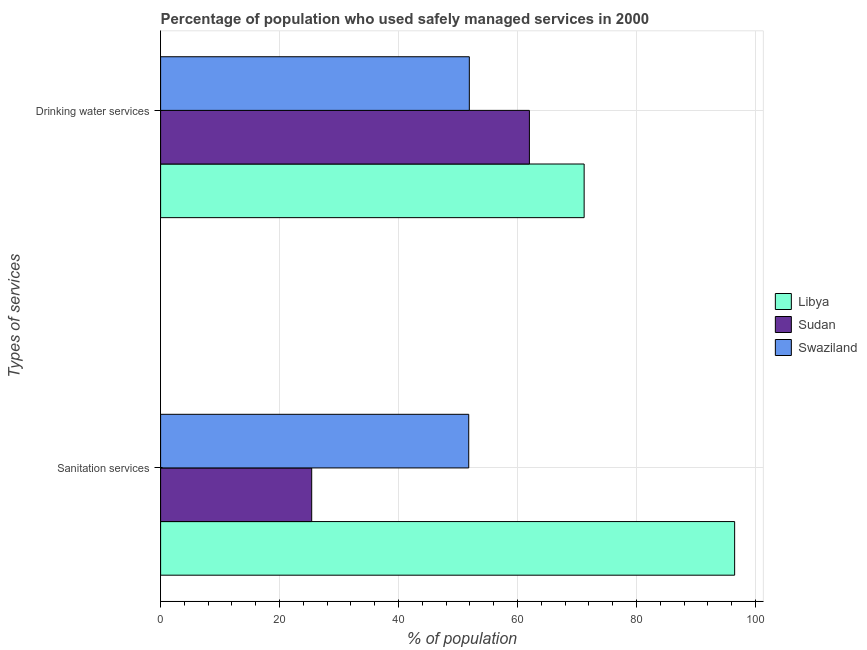How many different coloured bars are there?
Provide a succinct answer. 3. What is the label of the 1st group of bars from the top?
Ensure brevity in your answer.  Drinking water services. What is the percentage of population who used drinking water services in Libya?
Make the answer very short. 71.2. Across all countries, what is the maximum percentage of population who used sanitation services?
Offer a terse response. 96.5. Across all countries, what is the minimum percentage of population who used drinking water services?
Offer a terse response. 51.9. In which country was the percentage of population who used sanitation services maximum?
Offer a very short reply. Libya. In which country was the percentage of population who used drinking water services minimum?
Ensure brevity in your answer.  Swaziland. What is the total percentage of population who used drinking water services in the graph?
Your answer should be compact. 185.1. What is the difference between the percentage of population who used drinking water services in Swaziland and that in Libya?
Provide a succinct answer. -19.3. What is the difference between the percentage of population who used drinking water services in Libya and the percentage of population who used sanitation services in Swaziland?
Your response must be concise. 19.4. What is the average percentage of population who used sanitation services per country?
Offer a terse response. 57.9. What is the difference between the percentage of population who used sanitation services and percentage of population who used drinking water services in Libya?
Your answer should be very brief. 25.3. What is the ratio of the percentage of population who used sanitation services in Swaziland to that in Libya?
Keep it short and to the point. 0.54. Is the percentage of population who used sanitation services in Libya less than that in Swaziland?
Your answer should be very brief. No. What does the 2nd bar from the top in Sanitation services represents?
Your response must be concise. Sudan. What does the 2nd bar from the bottom in Drinking water services represents?
Ensure brevity in your answer.  Sudan. Are the values on the major ticks of X-axis written in scientific E-notation?
Provide a succinct answer. No. Does the graph contain grids?
Offer a very short reply. Yes. What is the title of the graph?
Make the answer very short. Percentage of population who used safely managed services in 2000. Does "Denmark" appear as one of the legend labels in the graph?
Your answer should be compact. No. What is the label or title of the X-axis?
Provide a succinct answer. % of population. What is the label or title of the Y-axis?
Provide a succinct answer. Types of services. What is the % of population of Libya in Sanitation services?
Ensure brevity in your answer.  96.5. What is the % of population of Sudan in Sanitation services?
Offer a very short reply. 25.4. What is the % of population in Swaziland in Sanitation services?
Provide a succinct answer. 51.8. What is the % of population in Libya in Drinking water services?
Provide a succinct answer. 71.2. What is the % of population of Sudan in Drinking water services?
Your answer should be compact. 62. What is the % of population of Swaziland in Drinking water services?
Provide a succinct answer. 51.9. Across all Types of services, what is the maximum % of population of Libya?
Your response must be concise. 96.5. Across all Types of services, what is the maximum % of population of Swaziland?
Offer a terse response. 51.9. Across all Types of services, what is the minimum % of population of Libya?
Your answer should be very brief. 71.2. Across all Types of services, what is the minimum % of population in Sudan?
Make the answer very short. 25.4. Across all Types of services, what is the minimum % of population in Swaziland?
Make the answer very short. 51.8. What is the total % of population of Libya in the graph?
Offer a terse response. 167.7. What is the total % of population in Sudan in the graph?
Make the answer very short. 87.4. What is the total % of population of Swaziland in the graph?
Make the answer very short. 103.7. What is the difference between the % of population in Libya in Sanitation services and that in Drinking water services?
Your response must be concise. 25.3. What is the difference between the % of population of Sudan in Sanitation services and that in Drinking water services?
Your response must be concise. -36.6. What is the difference between the % of population in Swaziland in Sanitation services and that in Drinking water services?
Your response must be concise. -0.1. What is the difference between the % of population of Libya in Sanitation services and the % of population of Sudan in Drinking water services?
Provide a succinct answer. 34.5. What is the difference between the % of population of Libya in Sanitation services and the % of population of Swaziland in Drinking water services?
Your answer should be compact. 44.6. What is the difference between the % of population of Sudan in Sanitation services and the % of population of Swaziland in Drinking water services?
Make the answer very short. -26.5. What is the average % of population of Libya per Types of services?
Offer a terse response. 83.85. What is the average % of population in Sudan per Types of services?
Keep it short and to the point. 43.7. What is the average % of population in Swaziland per Types of services?
Your answer should be very brief. 51.85. What is the difference between the % of population of Libya and % of population of Sudan in Sanitation services?
Keep it short and to the point. 71.1. What is the difference between the % of population of Libya and % of population of Swaziland in Sanitation services?
Your answer should be very brief. 44.7. What is the difference between the % of population of Sudan and % of population of Swaziland in Sanitation services?
Ensure brevity in your answer.  -26.4. What is the difference between the % of population in Libya and % of population in Sudan in Drinking water services?
Provide a short and direct response. 9.2. What is the difference between the % of population of Libya and % of population of Swaziland in Drinking water services?
Offer a very short reply. 19.3. What is the difference between the % of population in Sudan and % of population in Swaziland in Drinking water services?
Ensure brevity in your answer.  10.1. What is the ratio of the % of population in Libya in Sanitation services to that in Drinking water services?
Make the answer very short. 1.36. What is the ratio of the % of population of Sudan in Sanitation services to that in Drinking water services?
Offer a terse response. 0.41. What is the difference between the highest and the second highest % of population of Libya?
Your answer should be very brief. 25.3. What is the difference between the highest and the second highest % of population of Sudan?
Offer a very short reply. 36.6. What is the difference between the highest and the second highest % of population of Swaziland?
Your response must be concise. 0.1. What is the difference between the highest and the lowest % of population in Libya?
Provide a short and direct response. 25.3. What is the difference between the highest and the lowest % of population in Sudan?
Your answer should be very brief. 36.6. What is the difference between the highest and the lowest % of population of Swaziland?
Provide a short and direct response. 0.1. 